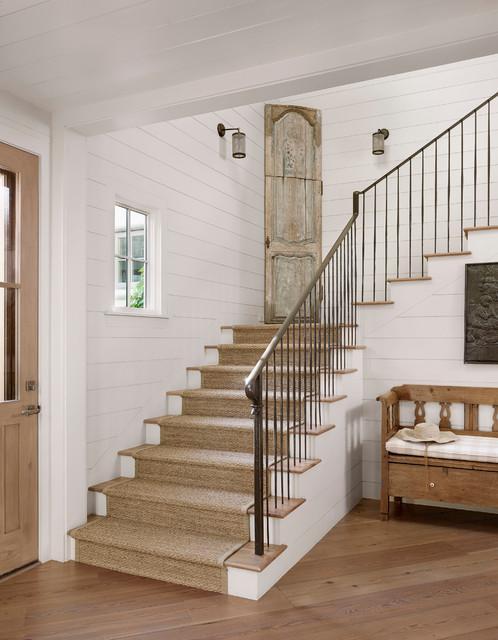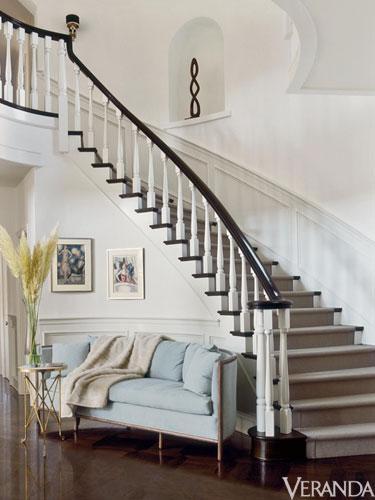The first image is the image on the left, the second image is the image on the right. Analyze the images presented: Is the assertion "There is a curved staircase." valid? Answer yes or no. Yes. The first image is the image on the left, the second image is the image on the right. Analyze the images presented: Is the assertion "The stairs in each image are going up toward the other image." valid? Answer yes or no. Yes. 